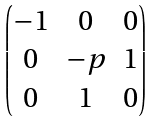Convert formula to latex. <formula><loc_0><loc_0><loc_500><loc_500>\begin{pmatrix} - 1 & 0 & 0 \\ 0 & - p & 1 \\ 0 & 1 & 0 \end{pmatrix}</formula> 